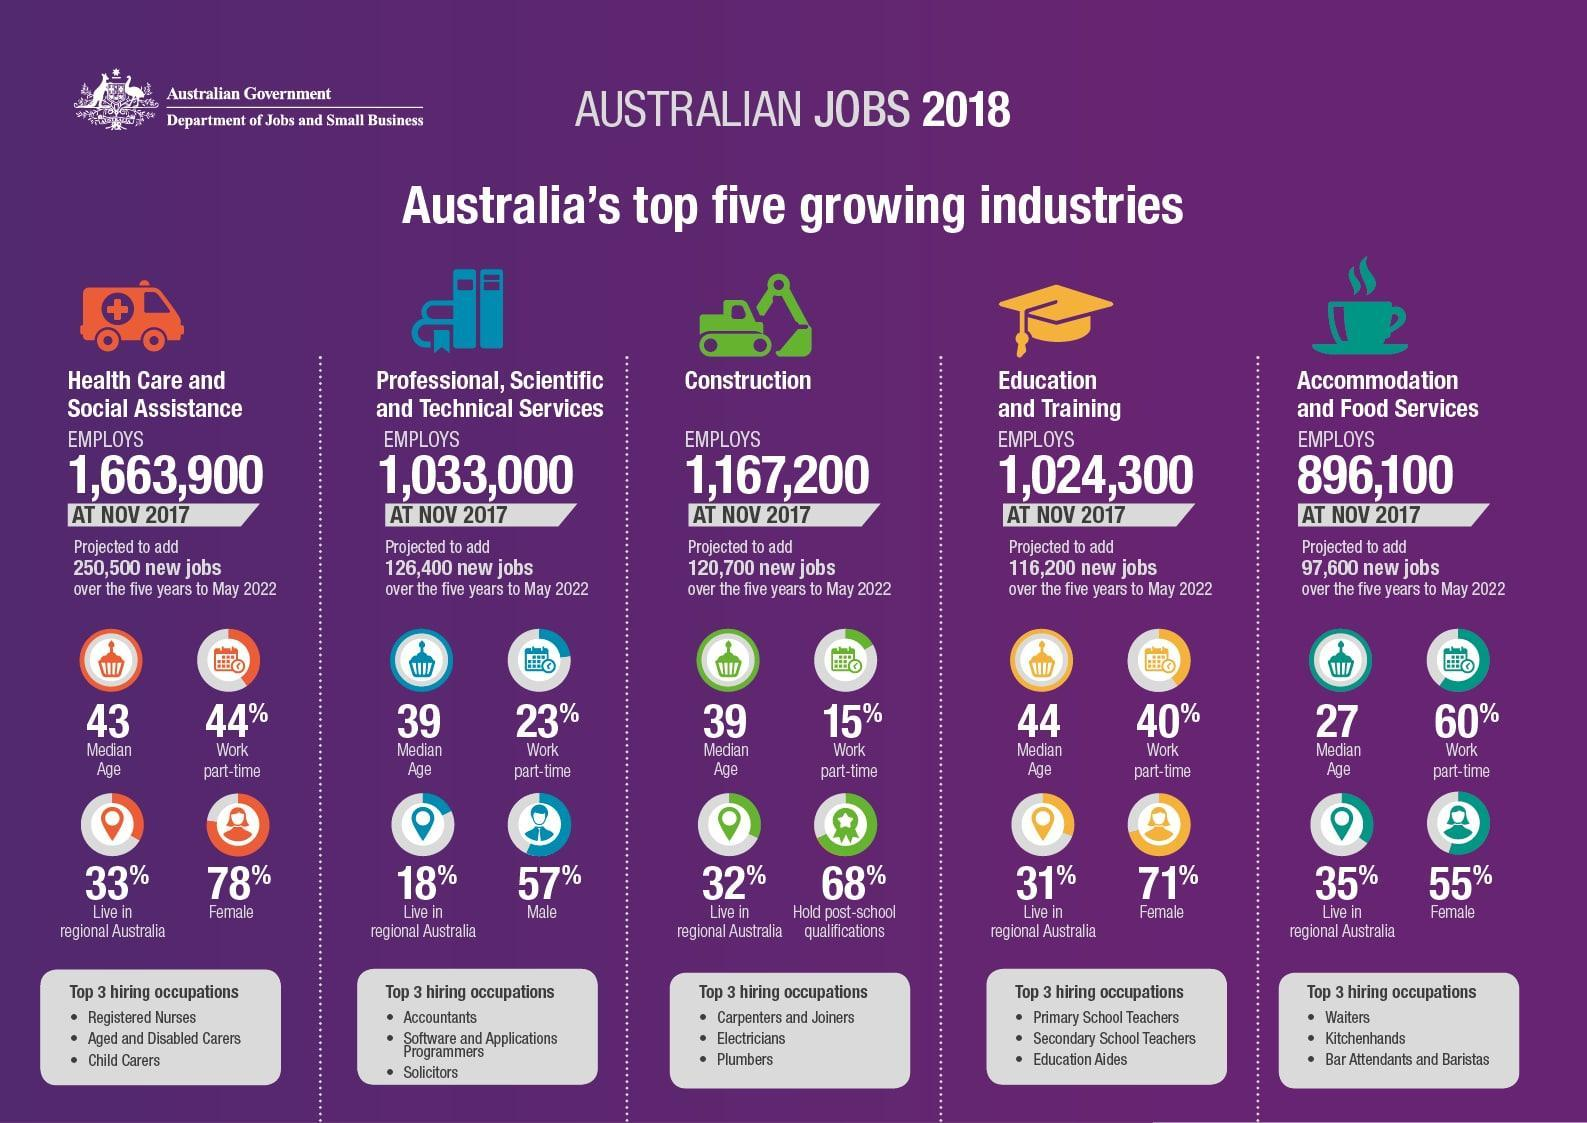What is the median age of employees working in the constuction field in Australia in the year 2018?
Answer the question with a short phrase. 39 What is the median age of employees working in the education & training institutions in Australia in the year 2018? 44 What is the number of employees working in Accomodation & Food Services in Australia in November 2017? 896,100 What percentage of employees work part time in the construction firm in Australia in 2018? 15% What percentage of employees working in the education & training institutions live in regional Australia in 2018? 31% What percentage of employees work part-time in the Professional, Scientific and Technical Services in Australia in 2018? 23% What is the number of employees working in education & training institutions in Australia in November 2017? 1,024,300 What percentage of employees working in the health care & social assistance services live in regional Australia in 2018? 33% What is the percentage of male employees working in the Professional, Scientific and Technical Services in Australia in 2018? 57% What is the percentage of female employees working in the Accomodation & Food Services in Australia in 2018? 55% 